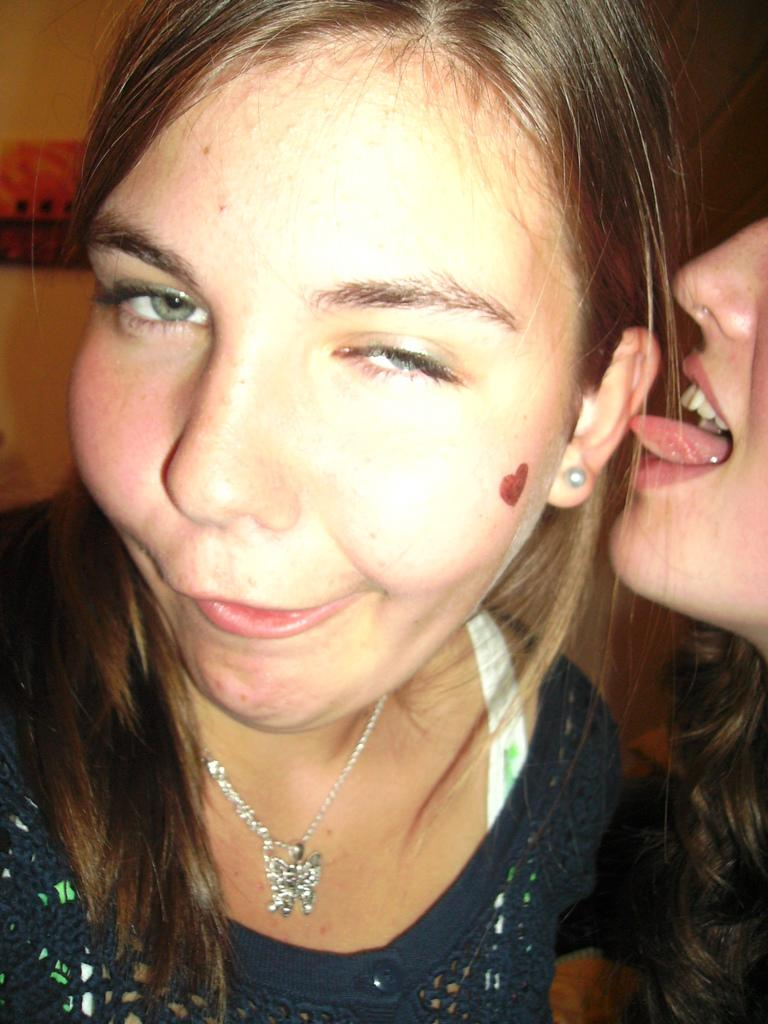Who is present in the image? There is a woman and another person in the image. Can you describe the background of the image? The background of the image is blurred. What type of story does the woman tell about the snakes in the image? There are no snakes present in the image, so it is not possible to answer that question. 